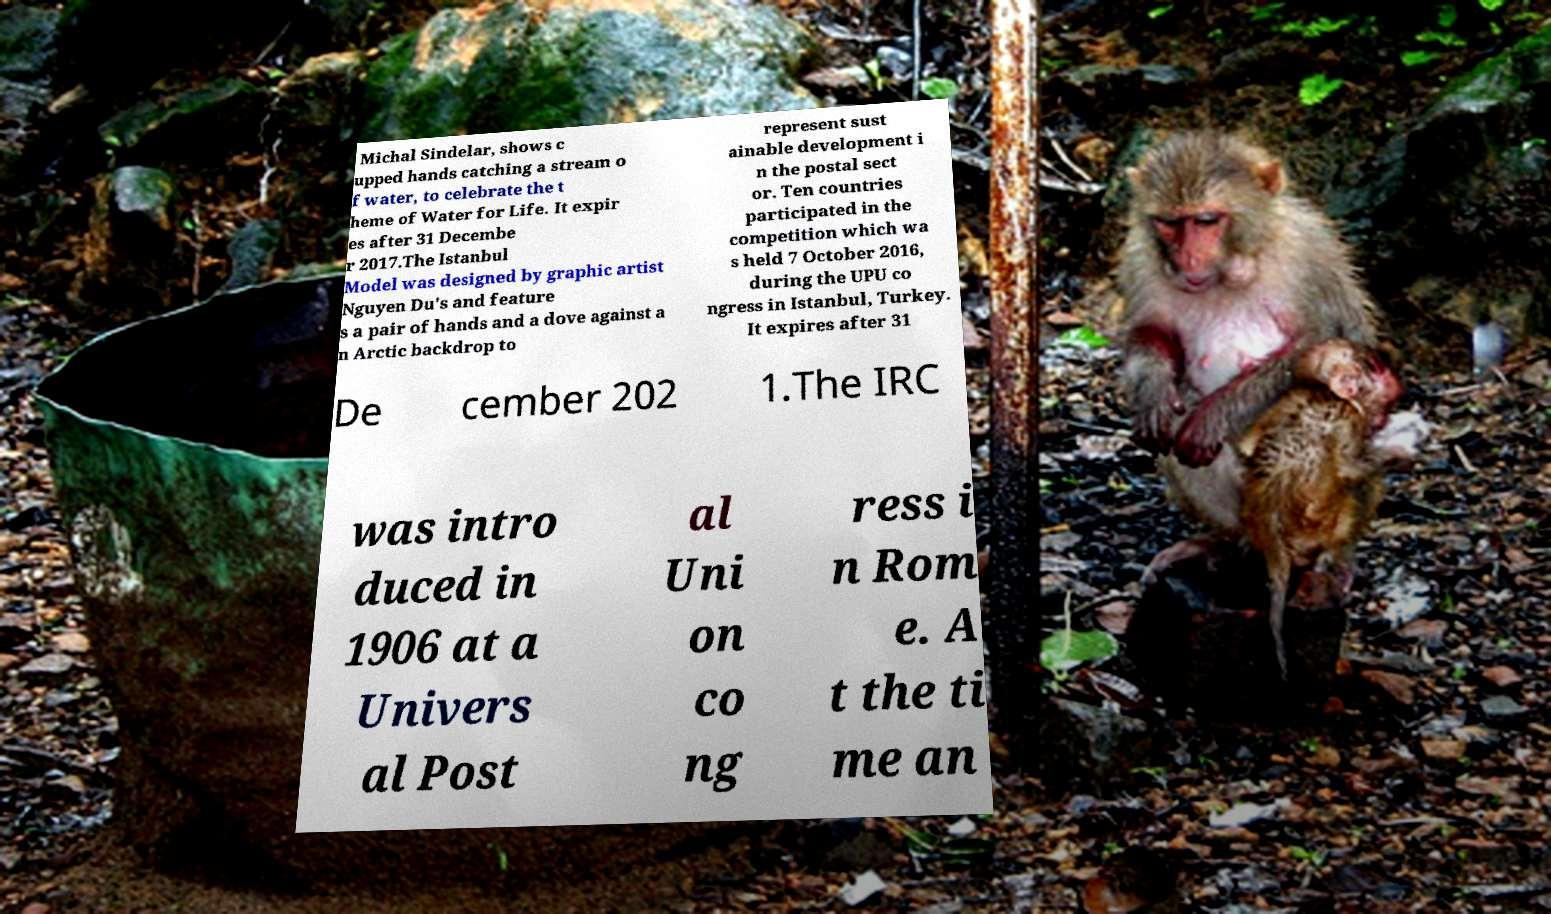There's text embedded in this image that I need extracted. Can you transcribe it verbatim? Michal Sindelar, shows c upped hands catching a stream o f water, to celebrate the t heme of Water for Life. It expir es after 31 Decembe r 2017.The Istanbul Model was designed by graphic artist Nguyen Du's and feature s a pair of hands and a dove against a n Arctic backdrop to represent sust ainable development i n the postal sect or. Ten countries participated in the competition which wa s held 7 October 2016, during the UPU co ngress in Istanbul, Turkey. It expires after 31 De cember 202 1.The IRC was intro duced in 1906 at a Univers al Post al Uni on co ng ress i n Rom e. A t the ti me an 